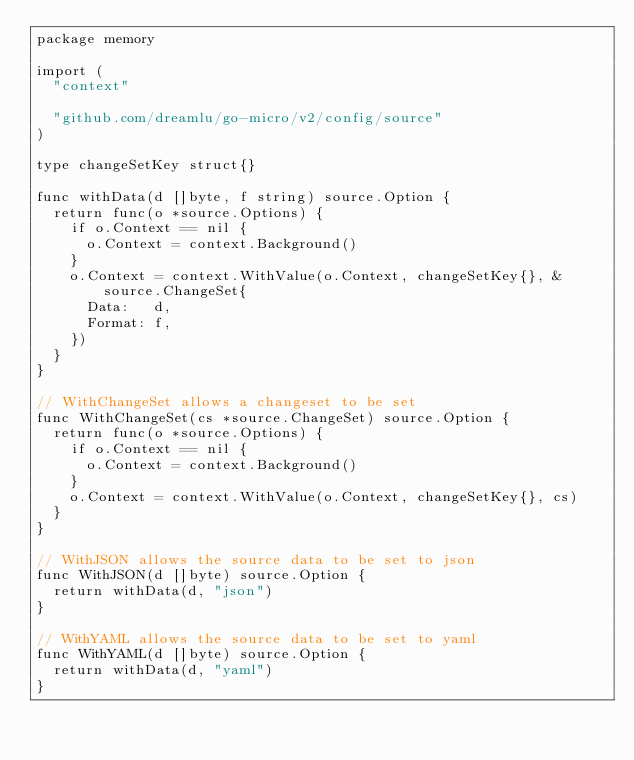<code> <loc_0><loc_0><loc_500><loc_500><_Go_>package memory

import (
	"context"

	"github.com/dreamlu/go-micro/v2/config/source"
)

type changeSetKey struct{}

func withData(d []byte, f string) source.Option {
	return func(o *source.Options) {
		if o.Context == nil {
			o.Context = context.Background()
		}
		o.Context = context.WithValue(o.Context, changeSetKey{}, &source.ChangeSet{
			Data:   d,
			Format: f,
		})
	}
}

// WithChangeSet allows a changeset to be set
func WithChangeSet(cs *source.ChangeSet) source.Option {
	return func(o *source.Options) {
		if o.Context == nil {
			o.Context = context.Background()
		}
		o.Context = context.WithValue(o.Context, changeSetKey{}, cs)
	}
}

// WithJSON allows the source data to be set to json
func WithJSON(d []byte) source.Option {
	return withData(d, "json")
}

// WithYAML allows the source data to be set to yaml
func WithYAML(d []byte) source.Option {
	return withData(d, "yaml")
}
</code> 